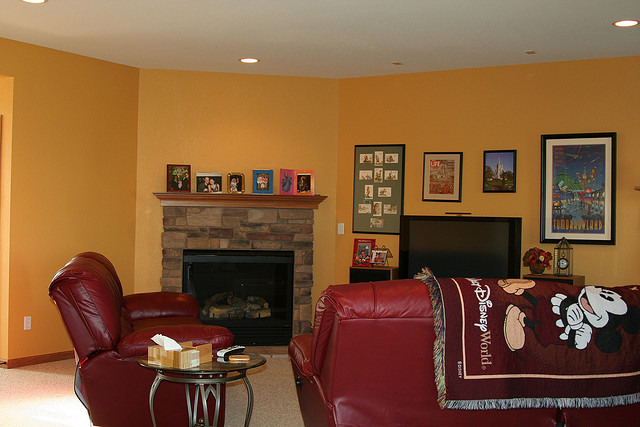Identify the text displayed in this image. DisNEY World 